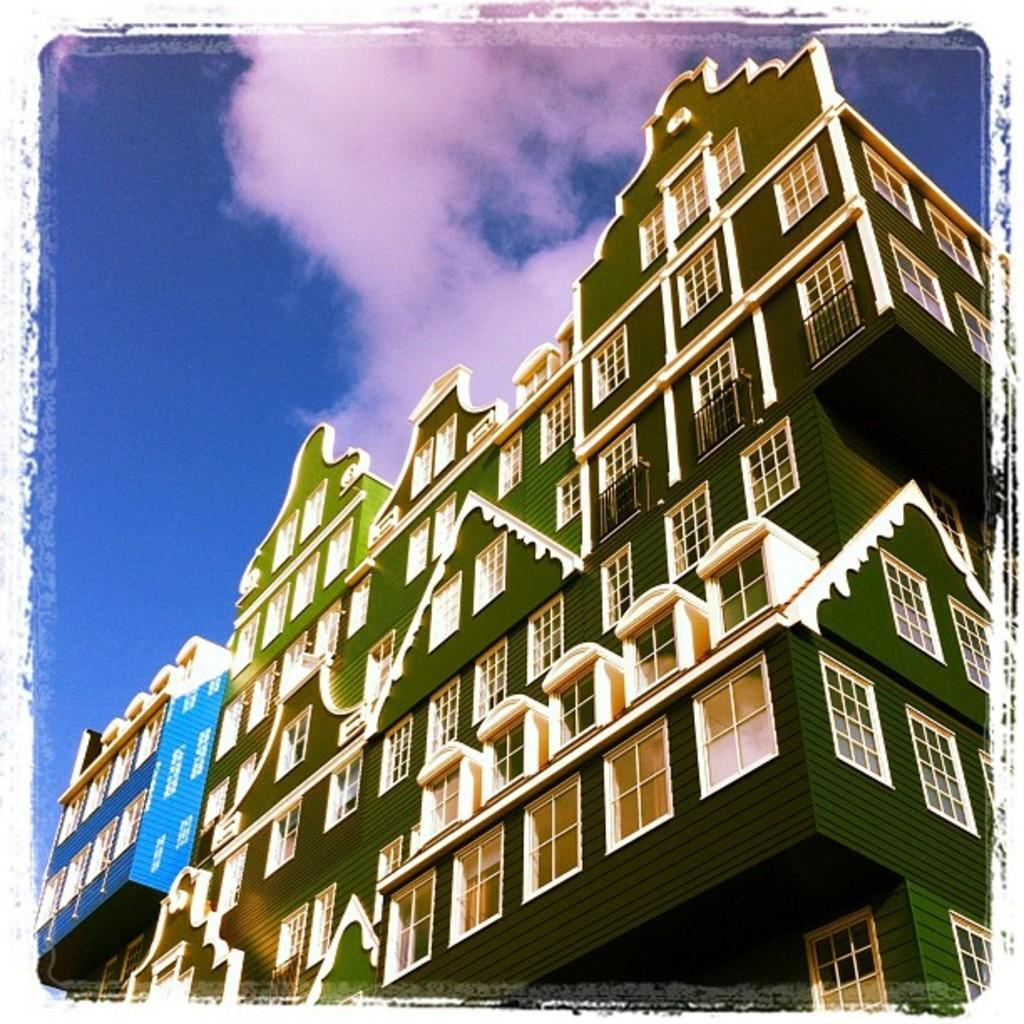What is the main structure in the image? There is a building in the image. What feature can be seen on the building? The building has windows. What is visible in the background of the image? The sky is visible in the image. What type of oil is being used to paint the building in the image? There is no indication in the image that the building is being painted, nor is there any mention of oil being used. 